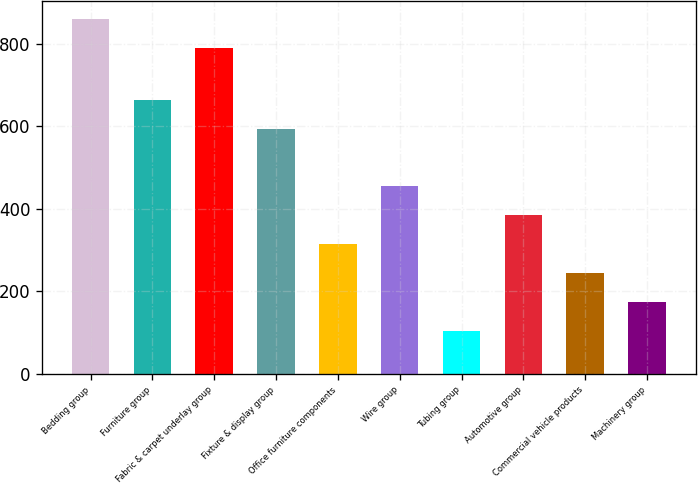<chart> <loc_0><loc_0><loc_500><loc_500><bar_chart><fcel>Bedding group<fcel>Furniture group<fcel>Fabric & carpet underlay group<fcel>Fixture & display group<fcel>Office furniture components<fcel>Wire group<fcel>Tubing group<fcel>Automotive group<fcel>Commercial vehicle products<fcel>Machinery group<nl><fcel>860.35<fcel>663.35<fcel>790.1<fcel>593.1<fcel>314.85<fcel>455.35<fcel>104.1<fcel>385.1<fcel>244.6<fcel>174.35<nl></chart> 